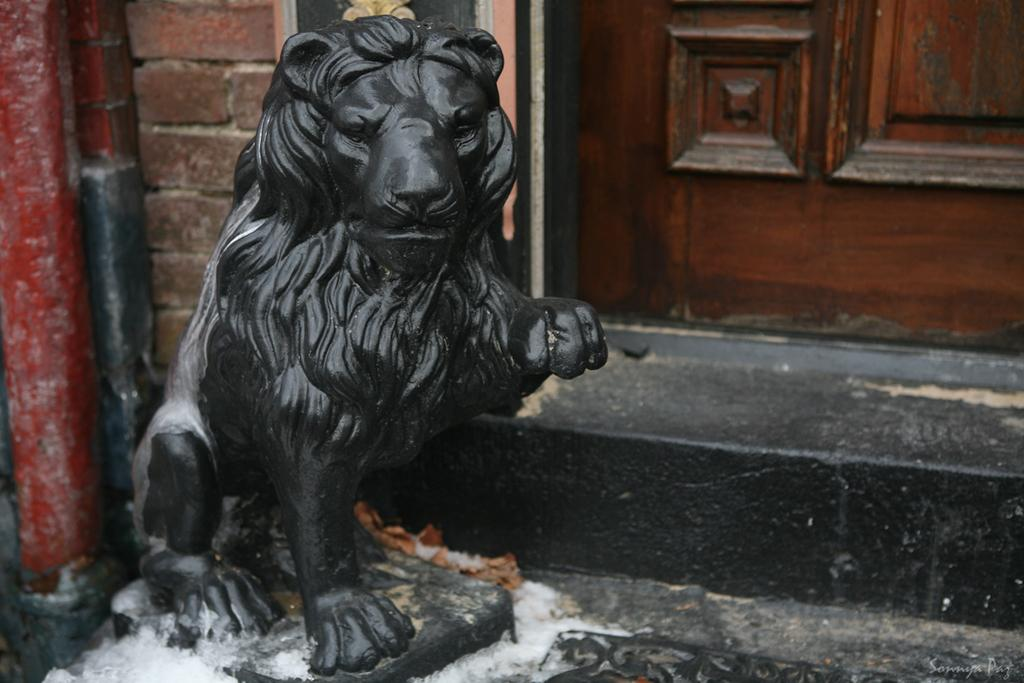What animal is depicted in the image? There is a depiction of a lion in the image. What type of structure can be seen in the background of the image? There is a wooden door in the background of the image. Can you see any volcanoes erupting in the image? There are no volcanoes present in the image. Is the lion in the image smiling? The image does not show the lion's facial expression, so it cannot be determined if the lion is smiling. 